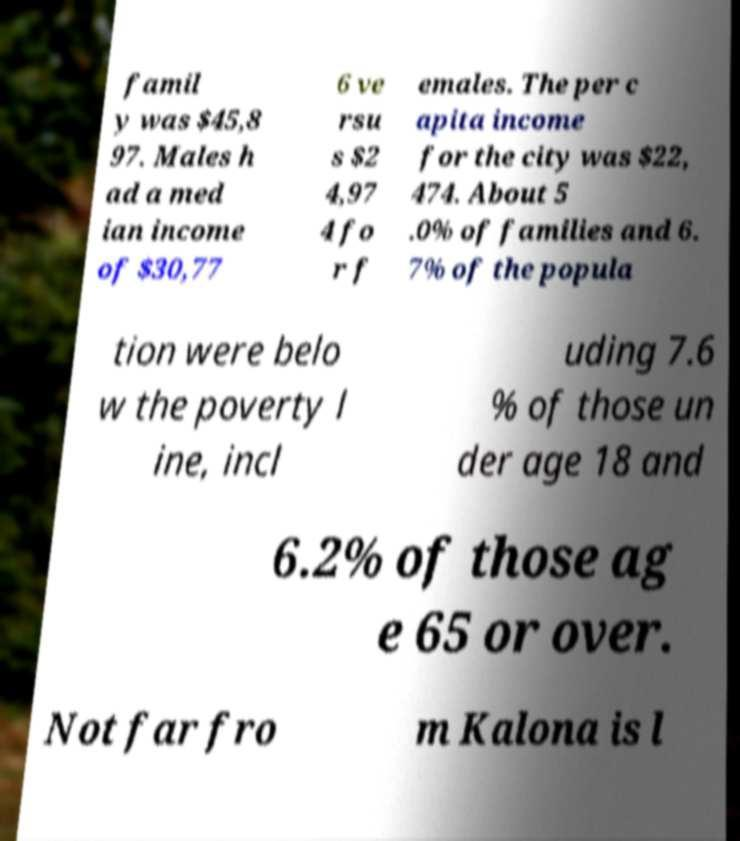Can you accurately transcribe the text from the provided image for me? famil y was $45,8 97. Males h ad a med ian income of $30,77 6 ve rsu s $2 4,97 4 fo r f emales. The per c apita income for the city was $22, 474. About 5 .0% of families and 6. 7% of the popula tion were belo w the poverty l ine, incl uding 7.6 % of those un der age 18 and 6.2% of those ag e 65 or over. Not far fro m Kalona is l 